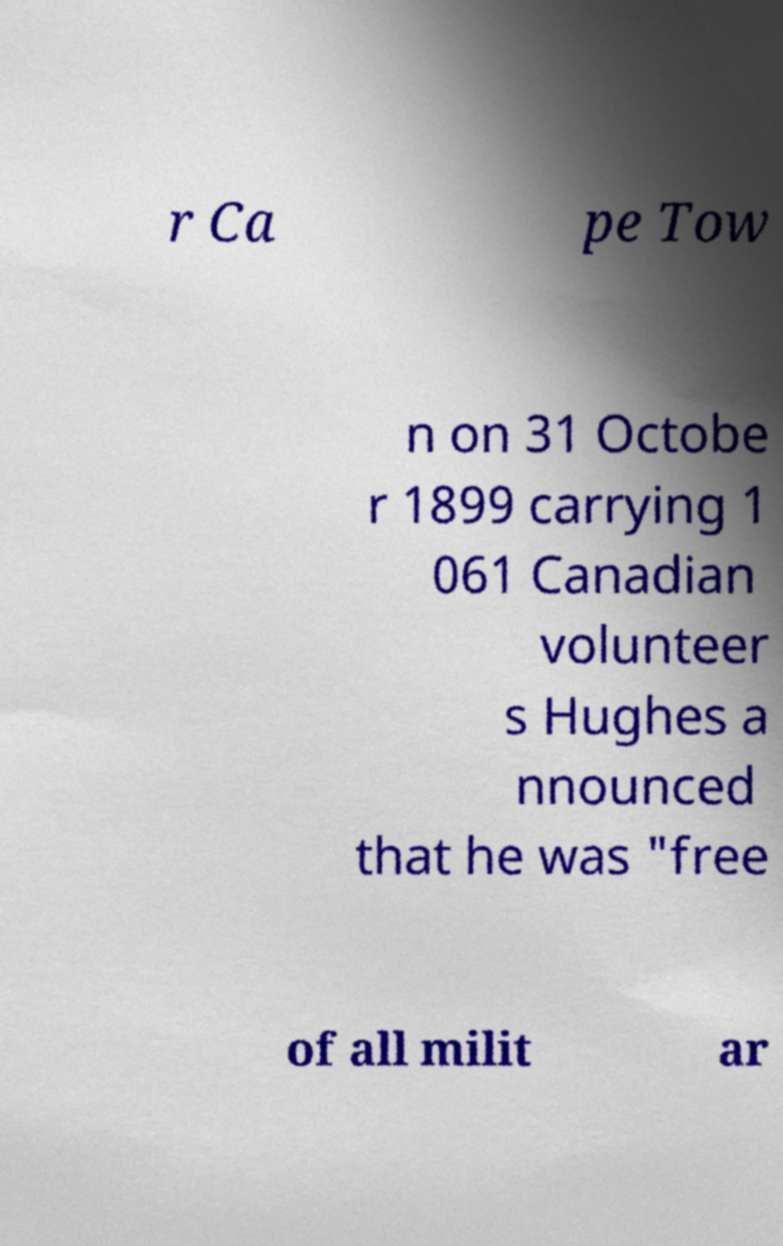There's text embedded in this image that I need extracted. Can you transcribe it verbatim? r Ca pe Tow n on 31 Octobe r 1899 carrying 1 061 Canadian volunteer s Hughes a nnounced that he was "free of all milit ar 